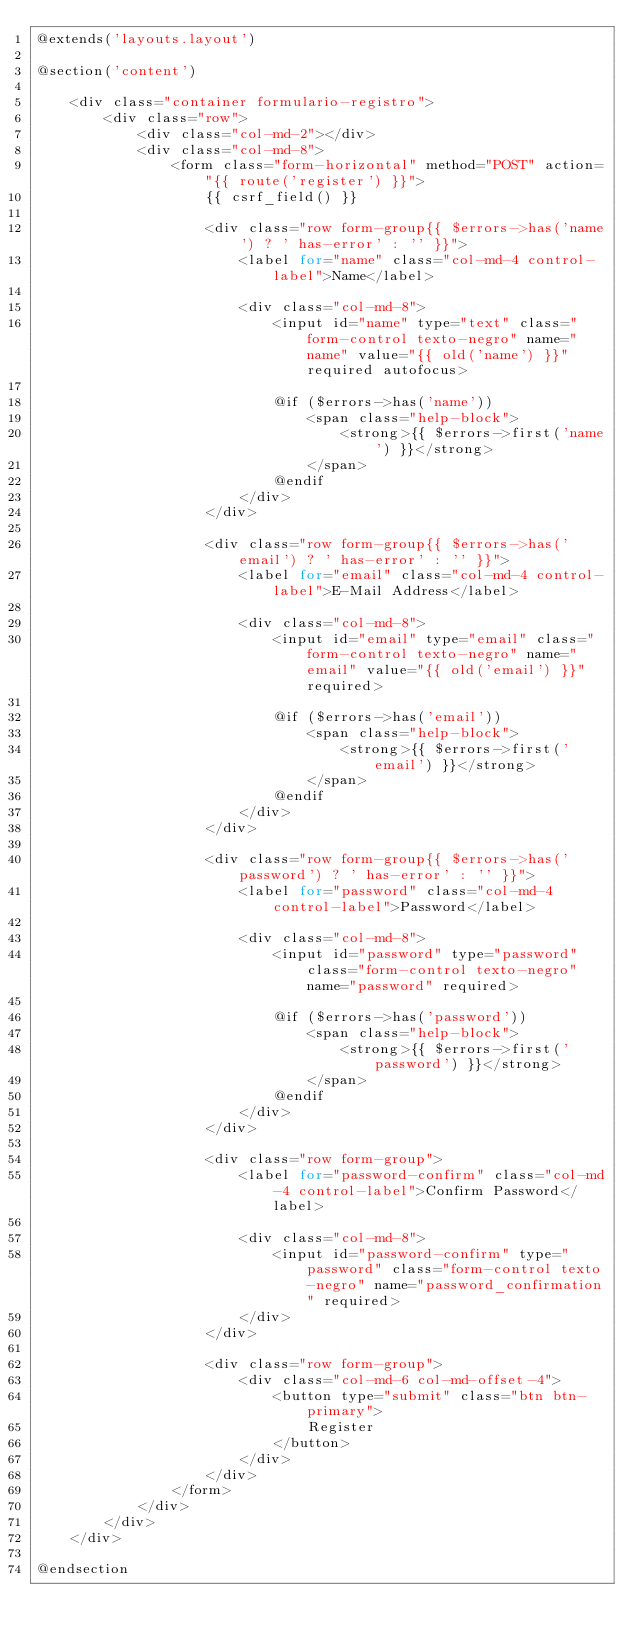Convert code to text. <code><loc_0><loc_0><loc_500><loc_500><_PHP_>@extends('layouts.layout')

@section('content')

    <div class="container formulario-registro">
        <div class="row">
            <div class="col-md-2"></div>
            <div class="col-md-8">
                <form class="form-horizontal" method="POST" action="{{ route('register') }}">
                    {{ csrf_field() }}

                    <div class="row form-group{{ $errors->has('name') ? ' has-error' : '' }}">
                        <label for="name" class="col-md-4 control-label">Name</label>

                        <div class="col-md-8">
                            <input id="name" type="text" class="form-control texto-negro" name="name" value="{{ old('name') }}" required autofocus>

                            @if ($errors->has('name'))
                                <span class="help-block">
                                    <strong>{{ $errors->first('name') }}</strong>
                                </span>
                            @endif
                        </div>
                    </div>

                    <div class="row form-group{{ $errors->has('email') ? ' has-error' : '' }}">
                        <label for="email" class="col-md-4 control-label">E-Mail Address</label>

                        <div class="col-md-8">
                            <input id="email" type="email" class="form-control texto-negro" name="email" value="{{ old('email') }}" required>

                            @if ($errors->has('email'))
                                <span class="help-block">
                                    <strong>{{ $errors->first('email') }}</strong>
                                </span>
                            @endif
                        </div>
                    </div>

                    <div class="row form-group{{ $errors->has('password') ? ' has-error' : '' }}">
                        <label for="password" class="col-md-4 control-label">Password</label>

                        <div class="col-md-8">
                            <input id="password" type="password" class="form-control texto-negro" name="password" required>

                            @if ($errors->has('password'))
                                <span class="help-block">
                                    <strong>{{ $errors->first('password') }}</strong>
                                </span>
                            @endif
                        </div>
                    </div>

                    <div class="row form-group">
                        <label for="password-confirm" class="col-md-4 control-label">Confirm Password</label>

                        <div class="col-md-8">
                            <input id="password-confirm" type="password" class="form-control texto-negro" name="password_confirmation" required>
                        </div>
                    </div>

                    <div class="row form-group">
                        <div class="col-md-6 col-md-offset-4">
                            <button type="submit" class="btn btn-primary">
                                Register
                            </button>
                        </div>
                    </div>
                </form>
            </div>
        </div>
    </div>

@endsection
</code> 